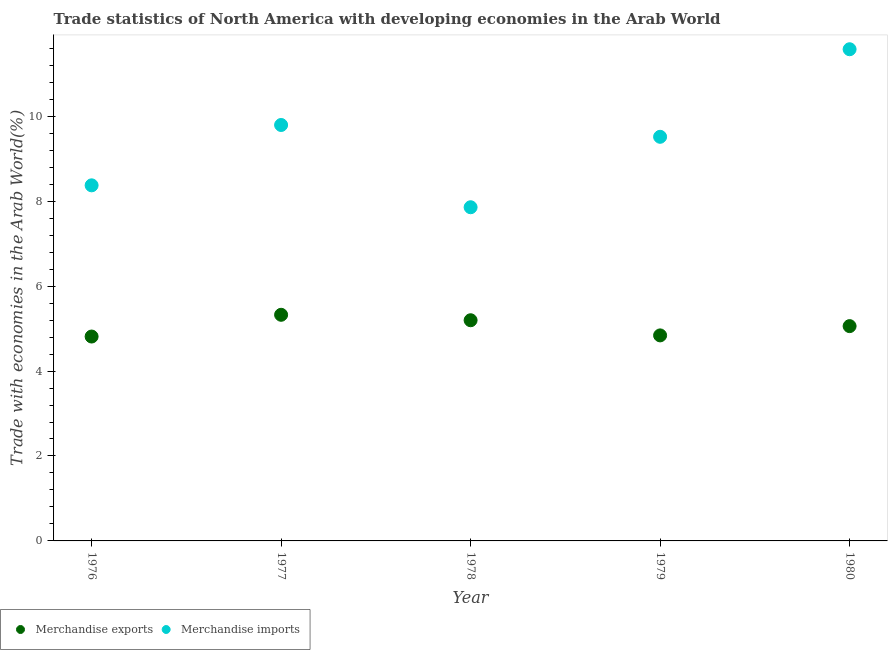What is the merchandise imports in 1980?
Your answer should be very brief. 11.58. Across all years, what is the maximum merchandise exports?
Provide a succinct answer. 5.32. Across all years, what is the minimum merchandise imports?
Your response must be concise. 7.86. In which year was the merchandise imports minimum?
Your response must be concise. 1978. What is the total merchandise exports in the graph?
Ensure brevity in your answer.  25.23. What is the difference between the merchandise imports in 1978 and that in 1979?
Your answer should be compact. -1.66. What is the difference between the merchandise exports in 1978 and the merchandise imports in 1980?
Your answer should be compact. -6.38. What is the average merchandise exports per year?
Offer a very short reply. 5.05. In the year 1977, what is the difference between the merchandise imports and merchandise exports?
Provide a short and direct response. 4.47. In how many years, is the merchandise imports greater than 7.2 %?
Ensure brevity in your answer.  5. What is the ratio of the merchandise imports in 1977 to that in 1979?
Make the answer very short. 1.03. Is the difference between the merchandise imports in 1976 and 1977 greater than the difference between the merchandise exports in 1976 and 1977?
Your answer should be compact. No. What is the difference between the highest and the second highest merchandise exports?
Your answer should be very brief. 0.13. What is the difference between the highest and the lowest merchandise exports?
Keep it short and to the point. 0.51. In how many years, is the merchandise imports greater than the average merchandise imports taken over all years?
Your answer should be very brief. 3. Is the merchandise imports strictly greater than the merchandise exports over the years?
Your answer should be very brief. Yes. Are the values on the major ticks of Y-axis written in scientific E-notation?
Give a very brief answer. No. Does the graph contain grids?
Keep it short and to the point. No. Where does the legend appear in the graph?
Offer a very short reply. Bottom left. How many legend labels are there?
Your answer should be very brief. 2. What is the title of the graph?
Ensure brevity in your answer.  Trade statistics of North America with developing economies in the Arab World. Does "Exports" appear as one of the legend labels in the graph?
Keep it short and to the point. No. What is the label or title of the X-axis?
Provide a succinct answer. Year. What is the label or title of the Y-axis?
Offer a very short reply. Trade with economies in the Arab World(%). What is the Trade with economies in the Arab World(%) of Merchandise exports in 1976?
Provide a succinct answer. 4.81. What is the Trade with economies in the Arab World(%) of Merchandise imports in 1976?
Make the answer very short. 8.37. What is the Trade with economies in the Arab World(%) in Merchandise exports in 1977?
Offer a terse response. 5.32. What is the Trade with economies in the Arab World(%) of Merchandise imports in 1977?
Give a very brief answer. 9.79. What is the Trade with economies in the Arab World(%) in Merchandise exports in 1978?
Provide a succinct answer. 5.2. What is the Trade with economies in the Arab World(%) in Merchandise imports in 1978?
Offer a terse response. 7.86. What is the Trade with economies in the Arab World(%) in Merchandise exports in 1979?
Your answer should be compact. 4.84. What is the Trade with economies in the Arab World(%) of Merchandise imports in 1979?
Provide a short and direct response. 9.52. What is the Trade with economies in the Arab World(%) in Merchandise exports in 1980?
Your response must be concise. 5.06. What is the Trade with economies in the Arab World(%) of Merchandise imports in 1980?
Provide a succinct answer. 11.58. Across all years, what is the maximum Trade with economies in the Arab World(%) of Merchandise exports?
Provide a short and direct response. 5.32. Across all years, what is the maximum Trade with economies in the Arab World(%) of Merchandise imports?
Provide a short and direct response. 11.58. Across all years, what is the minimum Trade with economies in the Arab World(%) in Merchandise exports?
Provide a short and direct response. 4.81. Across all years, what is the minimum Trade with economies in the Arab World(%) in Merchandise imports?
Provide a succinct answer. 7.86. What is the total Trade with economies in the Arab World(%) in Merchandise exports in the graph?
Your answer should be compact. 25.23. What is the total Trade with economies in the Arab World(%) in Merchandise imports in the graph?
Your response must be concise. 47.12. What is the difference between the Trade with economies in the Arab World(%) of Merchandise exports in 1976 and that in 1977?
Ensure brevity in your answer.  -0.51. What is the difference between the Trade with economies in the Arab World(%) in Merchandise imports in 1976 and that in 1977?
Your answer should be compact. -1.42. What is the difference between the Trade with economies in the Arab World(%) in Merchandise exports in 1976 and that in 1978?
Provide a succinct answer. -0.38. What is the difference between the Trade with economies in the Arab World(%) of Merchandise imports in 1976 and that in 1978?
Your answer should be very brief. 0.52. What is the difference between the Trade with economies in the Arab World(%) of Merchandise exports in 1976 and that in 1979?
Make the answer very short. -0.03. What is the difference between the Trade with economies in the Arab World(%) of Merchandise imports in 1976 and that in 1979?
Give a very brief answer. -1.14. What is the difference between the Trade with economies in the Arab World(%) in Merchandise exports in 1976 and that in 1980?
Make the answer very short. -0.25. What is the difference between the Trade with economies in the Arab World(%) in Merchandise imports in 1976 and that in 1980?
Your answer should be compact. -3.2. What is the difference between the Trade with economies in the Arab World(%) in Merchandise exports in 1977 and that in 1978?
Your answer should be very brief. 0.13. What is the difference between the Trade with economies in the Arab World(%) in Merchandise imports in 1977 and that in 1978?
Ensure brevity in your answer.  1.94. What is the difference between the Trade with economies in the Arab World(%) in Merchandise exports in 1977 and that in 1979?
Provide a succinct answer. 0.49. What is the difference between the Trade with economies in the Arab World(%) in Merchandise imports in 1977 and that in 1979?
Your response must be concise. 0.28. What is the difference between the Trade with economies in the Arab World(%) of Merchandise exports in 1977 and that in 1980?
Offer a very short reply. 0.27. What is the difference between the Trade with economies in the Arab World(%) in Merchandise imports in 1977 and that in 1980?
Your answer should be compact. -1.78. What is the difference between the Trade with economies in the Arab World(%) of Merchandise exports in 1978 and that in 1979?
Provide a succinct answer. 0.36. What is the difference between the Trade with economies in the Arab World(%) of Merchandise imports in 1978 and that in 1979?
Your answer should be compact. -1.66. What is the difference between the Trade with economies in the Arab World(%) of Merchandise exports in 1978 and that in 1980?
Provide a short and direct response. 0.14. What is the difference between the Trade with economies in the Arab World(%) of Merchandise imports in 1978 and that in 1980?
Make the answer very short. -3.72. What is the difference between the Trade with economies in the Arab World(%) in Merchandise exports in 1979 and that in 1980?
Offer a terse response. -0.22. What is the difference between the Trade with economies in the Arab World(%) in Merchandise imports in 1979 and that in 1980?
Ensure brevity in your answer.  -2.06. What is the difference between the Trade with economies in the Arab World(%) of Merchandise exports in 1976 and the Trade with economies in the Arab World(%) of Merchandise imports in 1977?
Keep it short and to the point. -4.98. What is the difference between the Trade with economies in the Arab World(%) of Merchandise exports in 1976 and the Trade with economies in the Arab World(%) of Merchandise imports in 1978?
Your response must be concise. -3.04. What is the difference between the Trade with economies in the Arab World(%) of Merchandise exports in 1976 and the Trade with economies in the Arab World(%) of Merchandise imports in 1979?
Your answer should be very brief. -4.7. What is the difference between the Trade with economies in the Arab World(%) in Merchandise exports in 1976 and the Trade with economies in the Arab World(%) in Merchandise imports in 1980?
Your answer should be very brief. -6.76. What is the difference between the Trade with economies in the Arab World(%) in Merchandise exports in 1977 and the Trade with economies in the Arab World(%) in Merchandise imports in 1978?
Keep it short and to the point. -2.53. What is the difference between the Trade with economies in the Arab World(%) of Merchandise exports in 1977 and the Trade with economies in the Arab World(%) of Merchandise imports in 1979?
Ensure brevity in your answer.  -4.19. What is the difference between the Trade with economies in the Arab World(%) in Merchandise exports in 1977 and the Trade with economies in the Arab World(%) in Merchandise imports in 1980?
Offer a terse response. -6.25. What is the difference between the Trade with economies in the Arab World(%) of Merchandise exports in 1978 and the Trade with economies in the Arab World(%) of Merchandise imports in 1979?
Provide a succinct answer. -4.32. What is the difference between the Trade with economies in the Arab World(%) in Merchandise exports in 1978 and the Trade with economies in the Arab World(%) in Merchandise imports in 1980?
Your answer should be very brief. -6.38. What is the difference between the Trade with economies in the Arab World(%) in Merchandise exports in 1979 and the Trade with economies in the Arab World(%) in Merchandise imports in 1980?
Your response must be concise. -6.74. What is the average Trade with economies in the Arab World(%) of Merchandise exports per year?
Make the answer very short. 5.05. What is the average Trade with economies in the Arab World(%) of Merchandise imports per year?
Provide a succinct answer. 9.42. In the year 1976, what is the difference between the Trade with economies in the Arab World(%) in Merchandise exports and Trade with economies in the Arab World(%) in Merchandise imports?
Provide a succinct answer. -3.56. In the year 1977, what is the difference between the Trade with economies in the Arab World(%) in Merchandise exports and Trade with economies in the Arab World(%) in Merchandise imports?
Provide a succinct answer. -4.47. In the year 1978, what is the difference between the Trade with economies in the Arab World(%) in Merchandise exports and Trade with economies in the Arab World(%) in Merchandise imports?
Your answer should be compact. -2.66. In the year 1979, what is the difference between the Trade with economies in the Arab World(%) of Merchandise exports and Trade with economies in the Arab World(%) of Merchandise imports?
Offer a terse response. -4.68. In the year 1980, what is the difference between the Trade with economies in the Arab World(%) of Merchandise exports and Trade with economies in the Arab World(%) of Merchandise imports?
Offer a terse response. -6.52. What is the ratio of the Trade with economies in the Arab World(%) in Merchandise exports in 1976 to that in 1977?
Keep it short and to the point. 0.9. What is the ratio of the Trade with economies in the Arab World(%) in Merchandise imports in 1976 to that in 1977?
Your response must be concise. 0.85. What is the ratio of the Trade with economies in the Arab World(%) in Merchandise exports in 1976 to that in 1978?
Offer a terse response. 0.93. What is the ratio of the Trade with economies in the Arab World(%) of Merchandise imports in 1976 to that in 1978?
Keep it short and to the point. 1.07. What is the ratio of the Trade with economies in the Arab World(%) in Merchandise imports in 1976 to that in 1979?
Offer a very short reply. 0.88. What is the ratio of the Trade with economies in the Arab World(%) of Merchandise exports in 1976 to that in 1980?
Give a very brief answer. 0.95. What is the ratio of the Trade with economies in the Arab World(%) of Merchandise imports in 1976 to that in 1980?
Offer a terse response. 0.72. What is the ratio of the Trade with economies in the Arab World(%) in Merchandise exports in 1977 to that in 1978?
Your answer should be very brief. 1.02. What is the ratio of the Trade with economies in the Arab World(%) in Merchandise imports in 1977 to that in 1978?
Your response must be concise. 1.25. What is the ratio of the Trade with economies in the Arab World(%) of Merchandise exports in 1977 to that in 1979?
Your answer should be very brief. 1.1. What is the ratio of the Trade with economies in the Arab World(%) of Merchandise imports in 1977 to that in 1979?
Make the answer very short. 1.03. What is the ratio of the Trade with economies in the Arab World(%) of Merchandise exports in 1977 to that in 1980?
Ensure brevity in your answer.  1.05. What is the ratio of the Trade with economies in the Arab World(%) of Merchandise imports in 1977 to that in 1980?
Offer a terse response. 0.85. What is the ratio of the Trade with economies in the Arab World(%) of Merchandise exports in 1978 to that in 1979?
Make the answer very short. 1.07. What is the ratio of the Trade with economies in the Arab World(%) of Merchandise imports in 1978 to that in 1979?
Ensure brevity in your answer.  0.83. What is the ratio of the Trade with economies in the Arab World(%) in Merchandise exports in 1978 to that in 1980?
Provide a short and direct response. 1.03. What is the ratio of the Trade with economies in the Arab World(%) in Merchandise imports in 1978 to that in 1980?
Ensure brevity in your answer.  0.68. What is the ratio of the Trade with economies in the Arab World(%) of Merchandise exports in 1979 to that in 1980?
Keep it short and to the point. 0.96. What is the ratio of the Trade with economies in the Arab World(%) of Merchandise imports in 1979 to that in 1980?
Keep it short and to the point. 0.82. What is the difference between the highest and the second highest Trade with economies in the Arab World(%) in Merchandise exports?
Your answer should be compact. 0.13. What is the difference between the highest and the second highest Trade with economies in the Arab World(%) in Merchandise imports?
Offer a very short reply. 1.78. What is the difference between the highest and the lowest Trade with economies in the Arab World(%) of Merchandise exports?
Give a very brief answer. 0.51. What is the difference between the highest and the lowest Trade with economies in the Arab World(%) in Merchandise imports?
Your answer should be very brief. 3.72. 